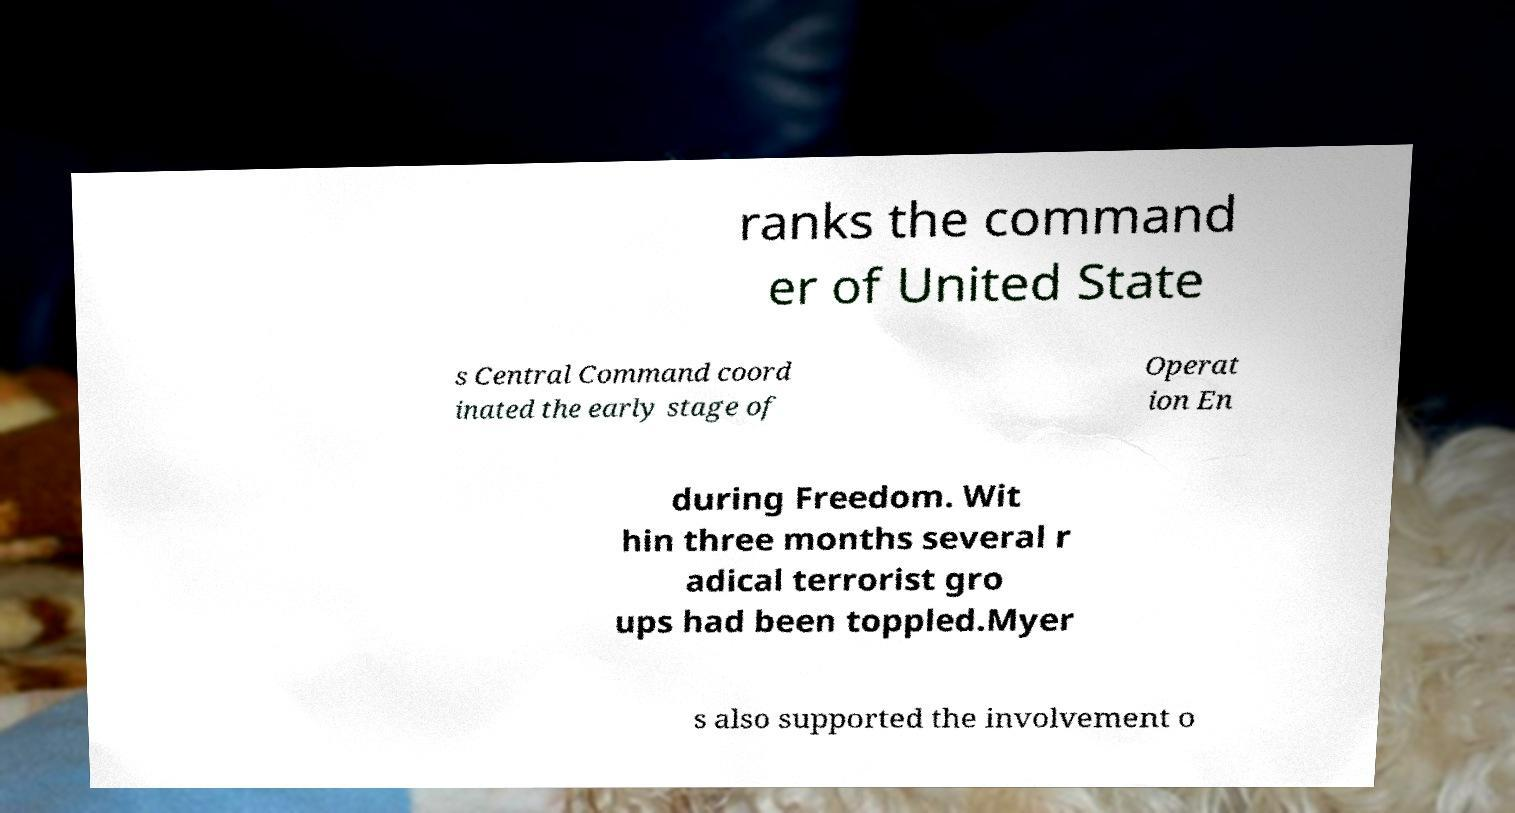Please read and relay the text visible in this image. What does it say? ranks the command er of United State s Central Command coord inated the early stage of Operat ion En during Freedom. Wit hin three months several r adical terrorist gro ups had been toppled.Myer s also supported the involvement o 